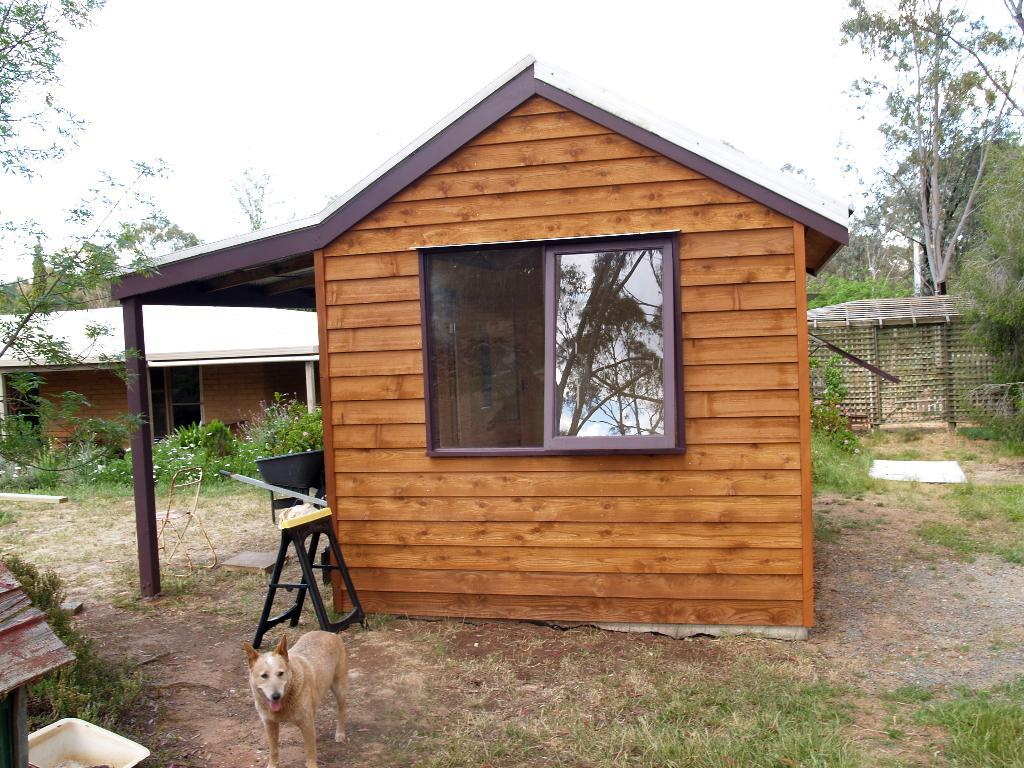What is the main structure in the image? There is a building in the image. What animal can be seen on the ground? There is a dog on the ground. What furniture is on the ground? There is a table on the ground. What object is on the ground, besides the table? There is a basket on the ground. What can be seen in the background of the image? There is a building, a shelter, and trees in the background of the image. What is the condition of the sky in the image? The sky is clear in the image. What type of stocking is the dog wearing in the image? There is no stocking present on the dog in the image. What material is the lead made of, which the dog is holding in the image? There is no lead present in the image, and the dog is not holding anything. 